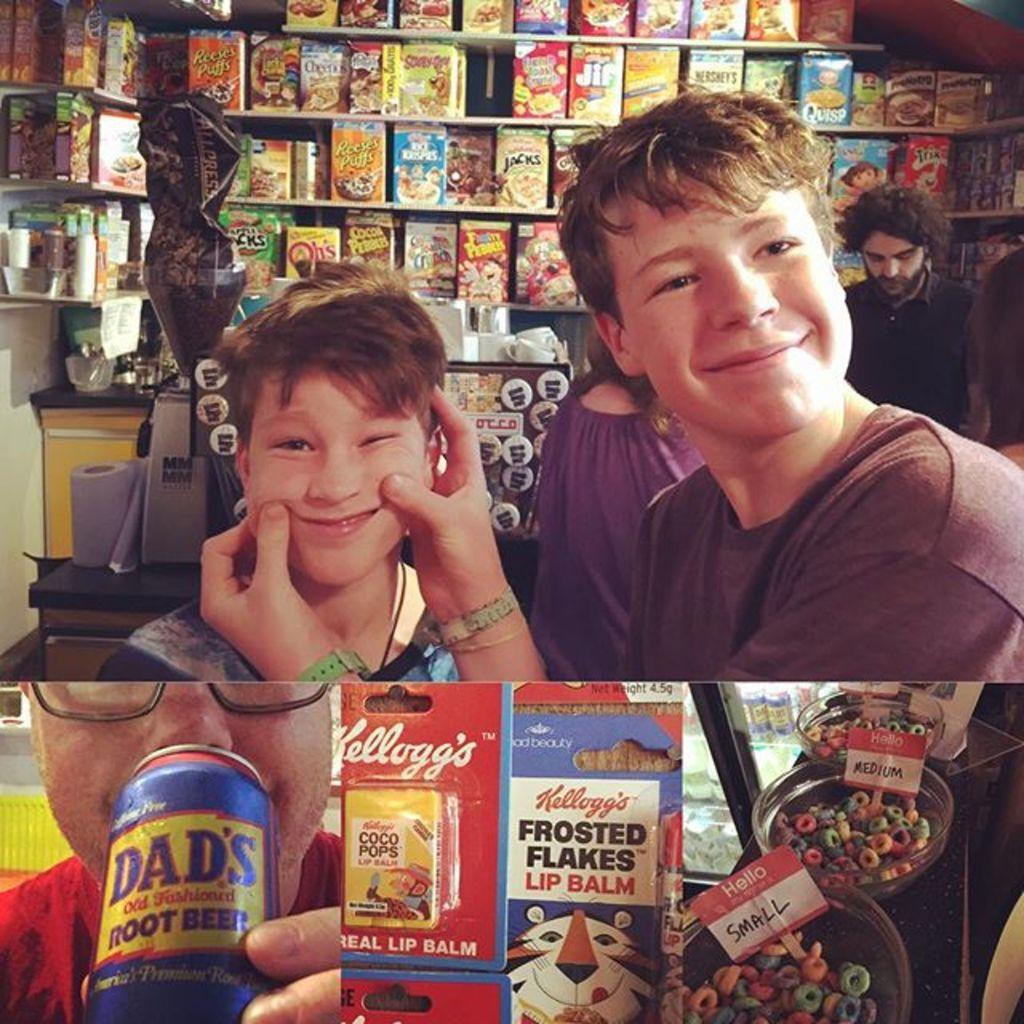Can you describe this image briefly? I see this is a collage pic and in this pic I see a person who is holding a can and there are few things over here and In this pic I see few people who are standing and these 2 are smiling. In the background I see lot of boxes in the racks. 